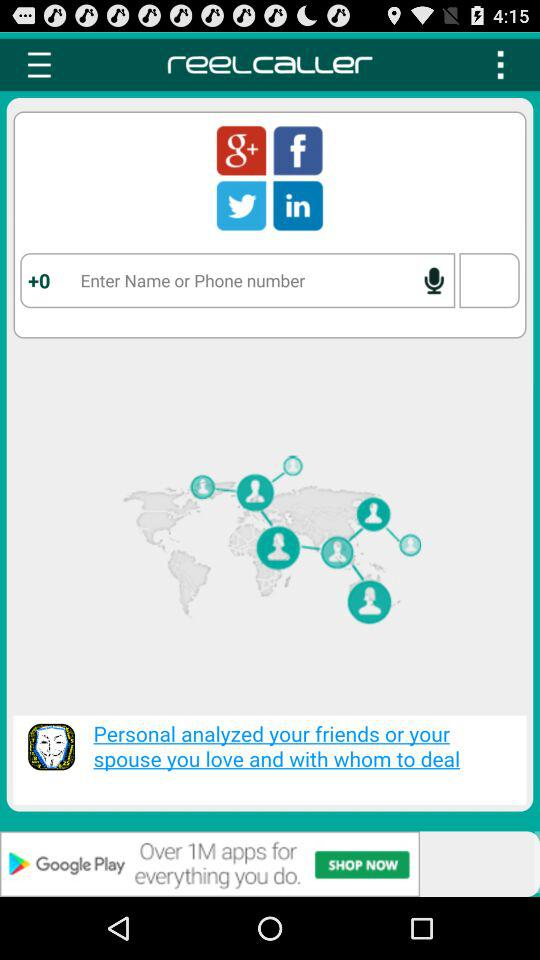What is the phone number?
When the provided information is insufficient, respond with <no answer>. <no answer> 